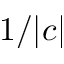<formula> <loc_0><loc_0><loc_500><loc_500>1 / | c |</formula> 